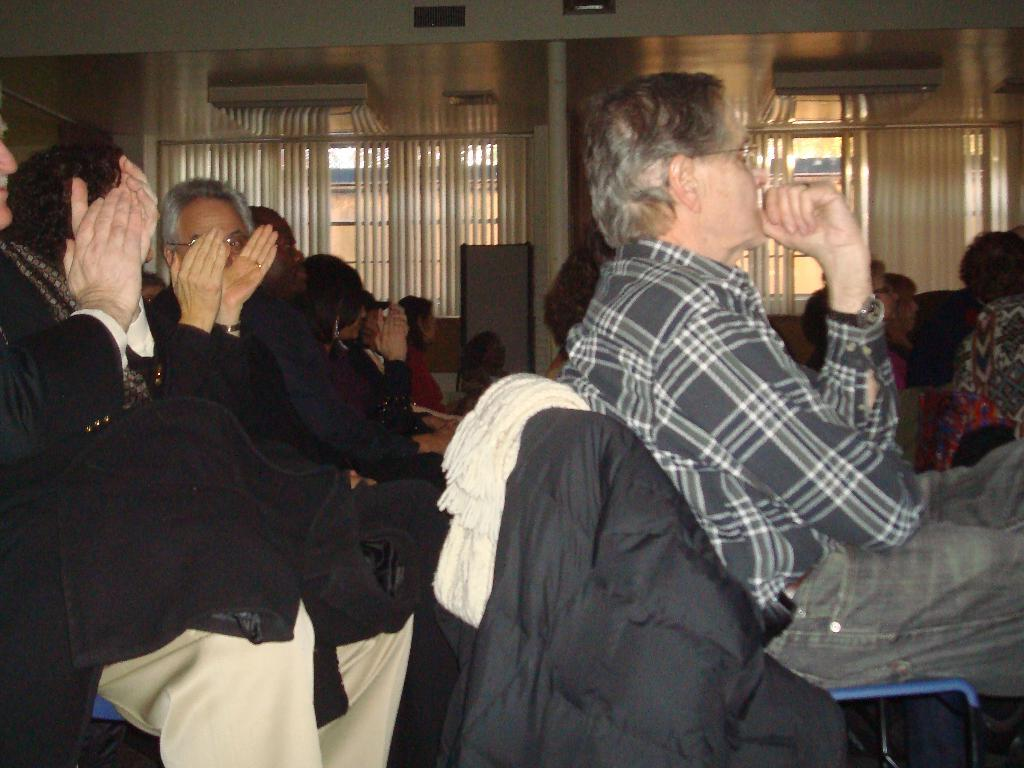What are the people in the image doing? The people in the image are sitting on chairs. What else can be seen in the image besides the people? Clothes are visible in the image, and there are windows in the background. Can you describe the object in the background? Unfortunately, the facts provided do not give enough information to describe the object in the background. What is visible at the top of the image? Lights are visible at the top of the image. What type of alarm is going off in the image? There is no alarm present in the image. How do the people in the image feel about their current situation? The facts provided do not give any information about the people's feelings or emotions. 